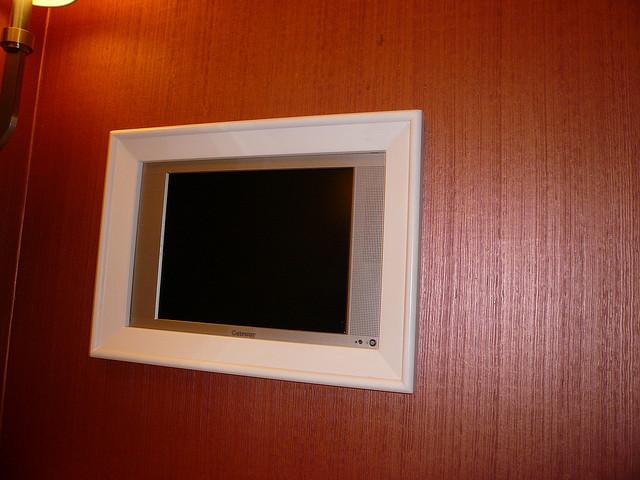What is on the wall?
Short answer required. Tv. What shape is this window?
Quick response, please. Rectangle. What is in the upper left corner?
Be succinct. Light. What color is the wall?
Quick response, please. Brown. 